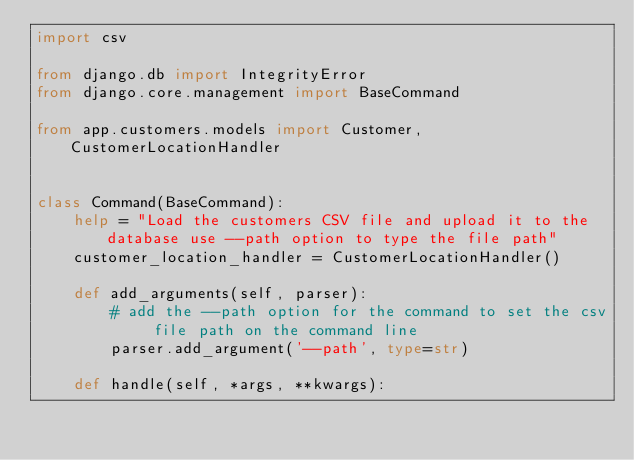Convert code to text. <code><loc_0><loc_0><loc_500><loc_500><_Python_>import csv

from django.db import IntegrityError
from django.core.management import BaseCommand

from app.customers.models import Customer, CustomerLocationHandler


class Command(BaseCommand):
    help = "Load the customers CSV file and upload it to the database use --path option to type the file path"
    customer_location_handler = CustomerLocationHandler()

    def add_arguments(self, parser):
        # add the --path option for the command to set the csv file path on the command line
        parser.add_argument('--path', type=str)

    def handle(self, *args, **kwargs):</code> 